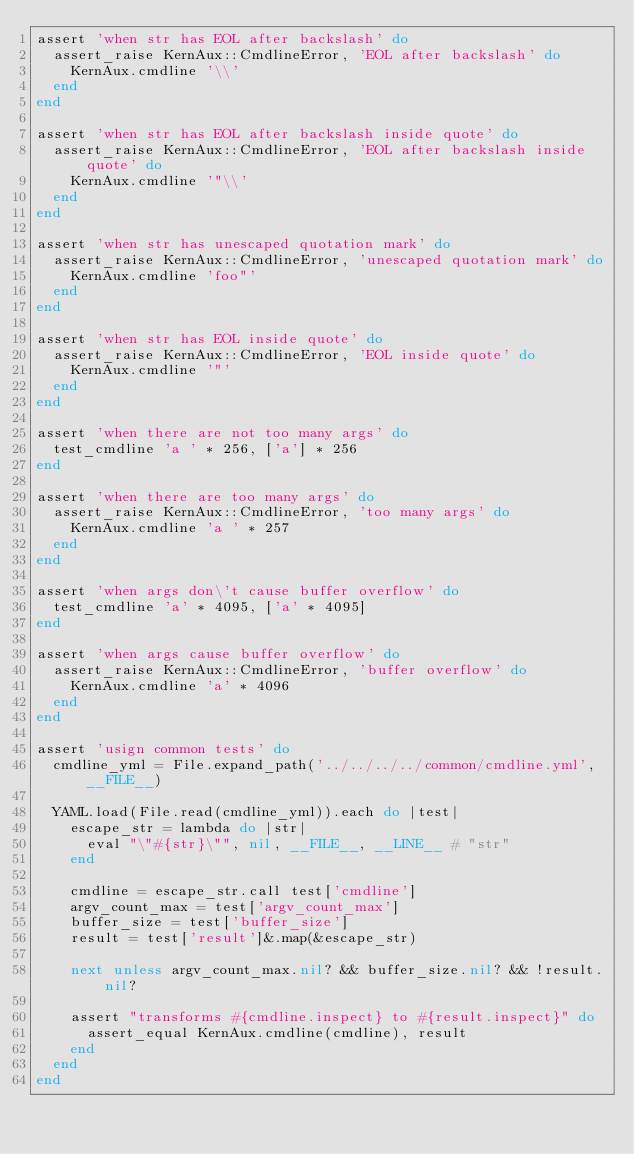Convert code to text. <code><loc_0><loc_0><loc_500><loc_500><_Ruby_>assert 'when str has EOL after backslash' do
  assert_raise KernAux::CmdlineError, 'EOL after backslash' do
    KernAux.cmdline '\\'
  end
end

assert 'when str has EOL after backslash inside quote' do
  assert_raise KernAux::CmdlineError, 'EOL after backslash inside quote' do
    KernAux.cmdline '"\\'
  end
end

assert 'when str has unescaped quotation mark' do
  assert_raise KernAux::CmdlineError, 'unescaped quotation mark' do
    KernAux.cmdline 'foo"'
  end
end

assert 'when str has EOL inside quote' do
  assert_raise KernAux::CmdlineError, 'EOL inside quote' do
    KernAux.cmdline '"'
  end
end

assert 'when there are not too many args' do
  test_cmdline 'a ' * 256, ['a'] * 256
end

assert 'when there are too many args' do
  assert_raise KernAux::CmdlineError, 'too many args' do
    KernAux.cmdline 'a ' * 257
  end
end

assert 'when args don\'t cause buffer overflow' do
  test_cmdline 'a' * 4095, ['a' * 4095]
end

assert 'when args cause buffer overflow' do
  assert_raise KernAux::CmdlineError, 'buffer overflow' do
    KernAux.cmdline 'a' * 4096
  end
end

assert 'usign common tests' do
  cmdline_yml = File.expand_path('../../../../common/cmdline.yml', __FILE__)

  YAML.load(File.read(cmdline_yml)).each do |test|
    escape_str = lambda do |str|
      eval "\"#{str}\"", nil, __FILE__, __LINE__ # "str"
    end

    cmdline = escape_str.call test['cmdline']
    argv_count_max = test['argv_count_max']
    buffer_size = test['buffer_size']
    result = test['result']&.map(&escape_str)

    next unless argv_count_max.nil? && buffer_size.nil? && !result.nil?

    assert "transforms #{cmdline.inspect} to #{result.inspect}" do
      assert_equal KernAux.cmdline(cmdline), result
    end
  end
end
</code> 